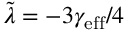<formula> <loc_0><loc_0><loc_500><loc_500>\tilde { \lambda } = - 3 \gamma _ { e f f } / 4</formula> 